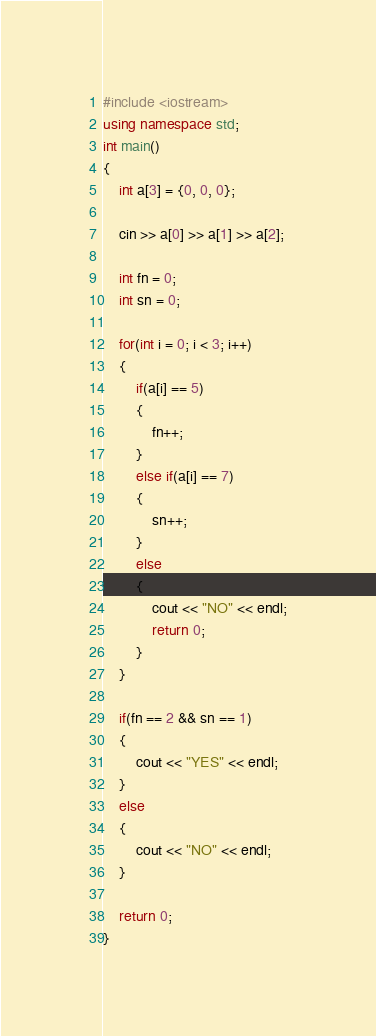Convert code to text. <code><loc_0><loc_0><loc_500><loc_500><_C++_>#include <iostream>
using namespace std;
int main()
{
    int a[3] = {0, 0, 0};

    cin >> a[0] >> a[1] >> a[2];

    int fn = 0;
    int sn = 0;

    for(int i = 0; i < 3; i++)
    {
        if(a[i] == 5)
        {
            fn++;
        }
        else if(a[i] == 7)
        {
            sn++;
        }
        else
        {
            cout << "NO" << endl;
            return 0;
        }
    }

    if(fn == 2 && sn == 1)
    {
        cout << "YES" << endl;
    }
    else
    {
        cout << "NO" << endl;
    }

    return 0;
}</code> 